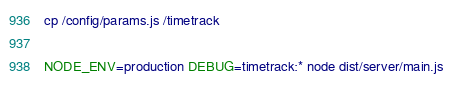<code> <loc_0><loc_0><loc_500><loc_500><_Bash_>cp /config/params.js /timetrack

NODE_ENV=production DEBUG=timetrack:* node dist/server/main.js
</code> 